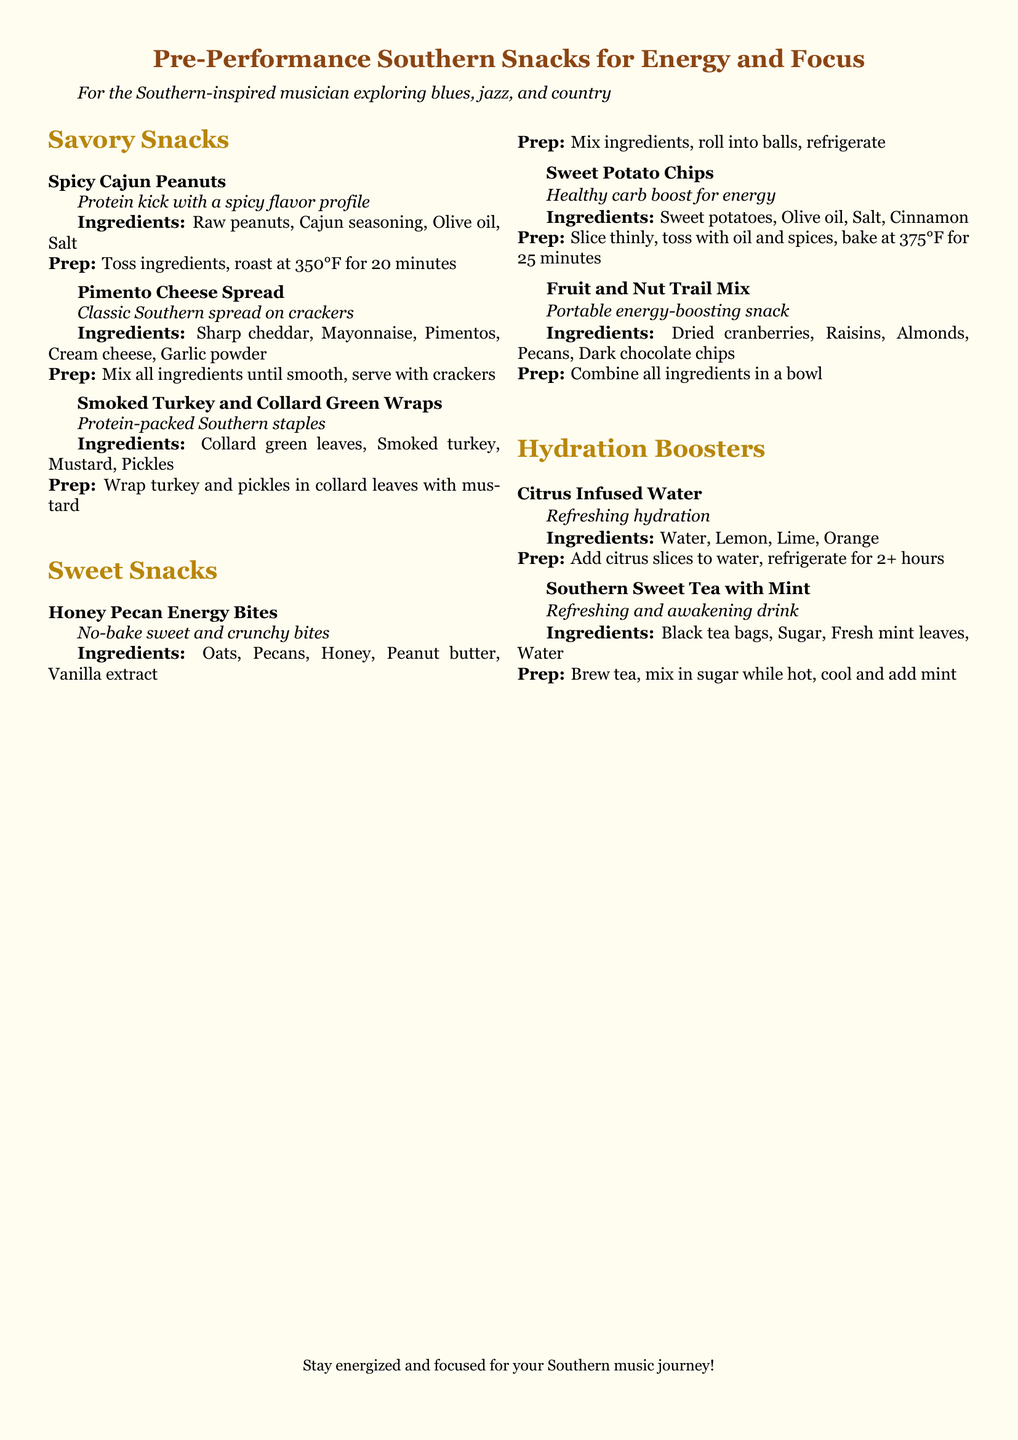What are the savory snacks listed? The document provides specific savory snacks, detailing examples like Spicy Cajun Peanuts and Pimento Cheese Spread.
Answer: Spicy Cajun Peanuts, Pimento Cheese Spread, Smoked Turkey and Collard Green Wraps How many hydration booster snacks are mentioned? The document lists two hydration booster snacks under the Hydration Boosters section.
Answer: 2 What ingredient is common in both sweet snacks? The sweet snacks share a common ingredient: honey, found in Honey Pecan Energy Bites.
Answer: Honey What is the preparation temperature for Sweet Potato Chips? The document specifies that Sweet Potato Chips should be baked at 375°F.
Answer: 375°F What type of tea is recommended as a hydration booster? The document mentions Southern Sweet Tea as a hydration booster drink.
Answer: Southern Sweet Tea What is the main ingredient of Pimento Cheese Spread? The document describes Sharp cheddar as the main ingredient in Pimento Cheese Spread.
Answer: Sharp cheddar How are the Honey Pecan Energy Bites prepared? The preparation involves mixing ingredients and rolling them into balls before refrigerating them.
Answer: Mix ingredients, roll into balls, refrigerate What kind of nuts are used in the Fruit and Nut Trail Mix? The document lists almonds and pecans as the nuts included in the Fruit and Nut Trail Mix.
Answer: Almonds, Pecans 